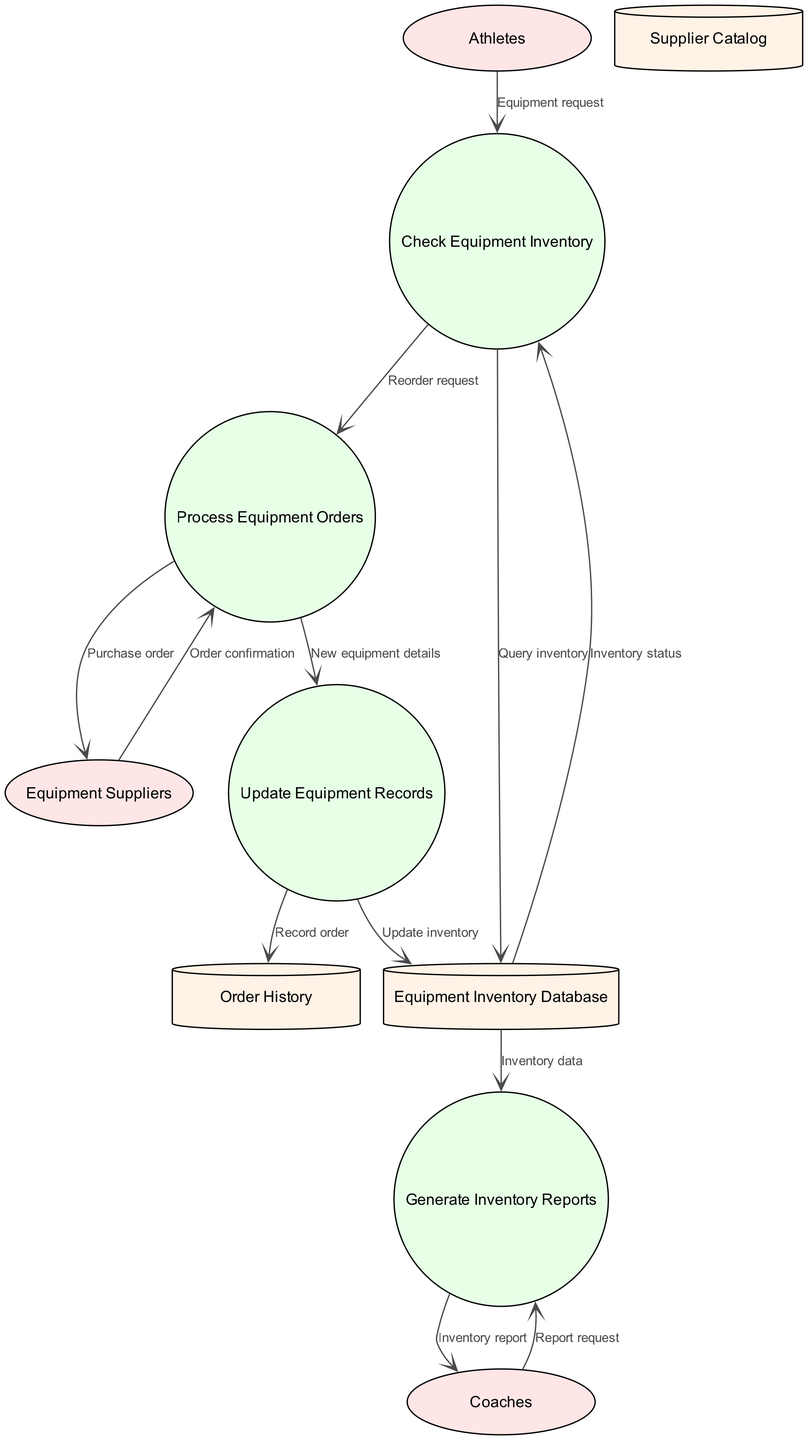What are the external entities depicted in the diagram? The diagram lists three external entities: Athletes, Equipment Suppliers, and Coaches. Each of these entities interacts with the processes defined in the diagram, indicating their roles within the equipment inventory and order management system.
Answer: Athletes, Equipment Suppliers, Coaches How many processes are shown in the diagram? The diagram includes four processes: Check Equipment Inventory, Process Equipment Orders, Update Equipment Records, and Generate Inventory Reports. Counting these processes provides a clear understanding of the various operations involved in managing equipment.
Answer: 4 What does the 'Check Equipment Inventory' process receive from 'Athletes'? The 'Check Equipment Inventory' process receives an 'Equipment request' from 'Athletes'. This flow indicates that athletes initiate the process by requesting information about available equipment.
Answer: Equipment request From which process does the 'Reorder request' flow into 'Process Equipment Orders'? The 'Reorder request' flows from the 'Check Equipment Inventory' process into the 'Process Equipment Orders'. This flow represents the action taken after checking the inventory, leading to an order for new equipment if necessary.
Answer: Check Equipment Inventory What data store is updated after 'Update Equipment Records'? After the 'Update Equipment Records' process, the 'Equipment Inventory Database' is updated. This shows that the inventory records are maintained in the data store for future reference and management.
Answer: Equipment Inventory Database Which external entity generates reports and what process do they interact with? Coaches generate reports by interacting with the 'Generate Inventory Reports' process. This interaction signifies the role of coaches in tracking and understanding the equipment inventory status.
Answer: Coaches, Generate Inventory Reports What information does the 'Generate Inventory Reports' process receive from the 'Equipment Inventory Database'? The 'Generate Inventory Reports' process receives 'Inventory data' from the 'Equipment Inventory Database'. This data is essential for creating accurate and informative reports for the coaches.
Answer: Inventory data How does 'Equipment Suppliers' contribute to the 'Process Equipment Orders'? 'Equipment Suppliers' contribute by sending an 'Order confirmation' back to 'Process Equipment Orders'. This signifies that the suppliers acknowledge the purchase order placed through the process.
Answer: Order confirmation What is the purpose of the 'Order History' data store? The 'Order History' data store is used to 'Record order' after the 'Update Equipment Records' process. This purpose highlights the importance of maintaining a history of past orders for tracking and management.
Answer: Record order 